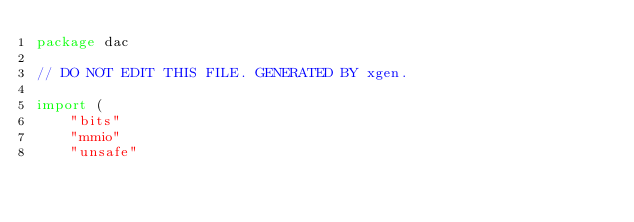Convert code to text. <code><loc_0><loc_0><loc_500><loc_500><_Go_>package dac

// DO NOT EDIT THIS FILE. GENERATED BY xgen.

import (
	"bits"
	"mmio"
	"unsafe"
</code> 